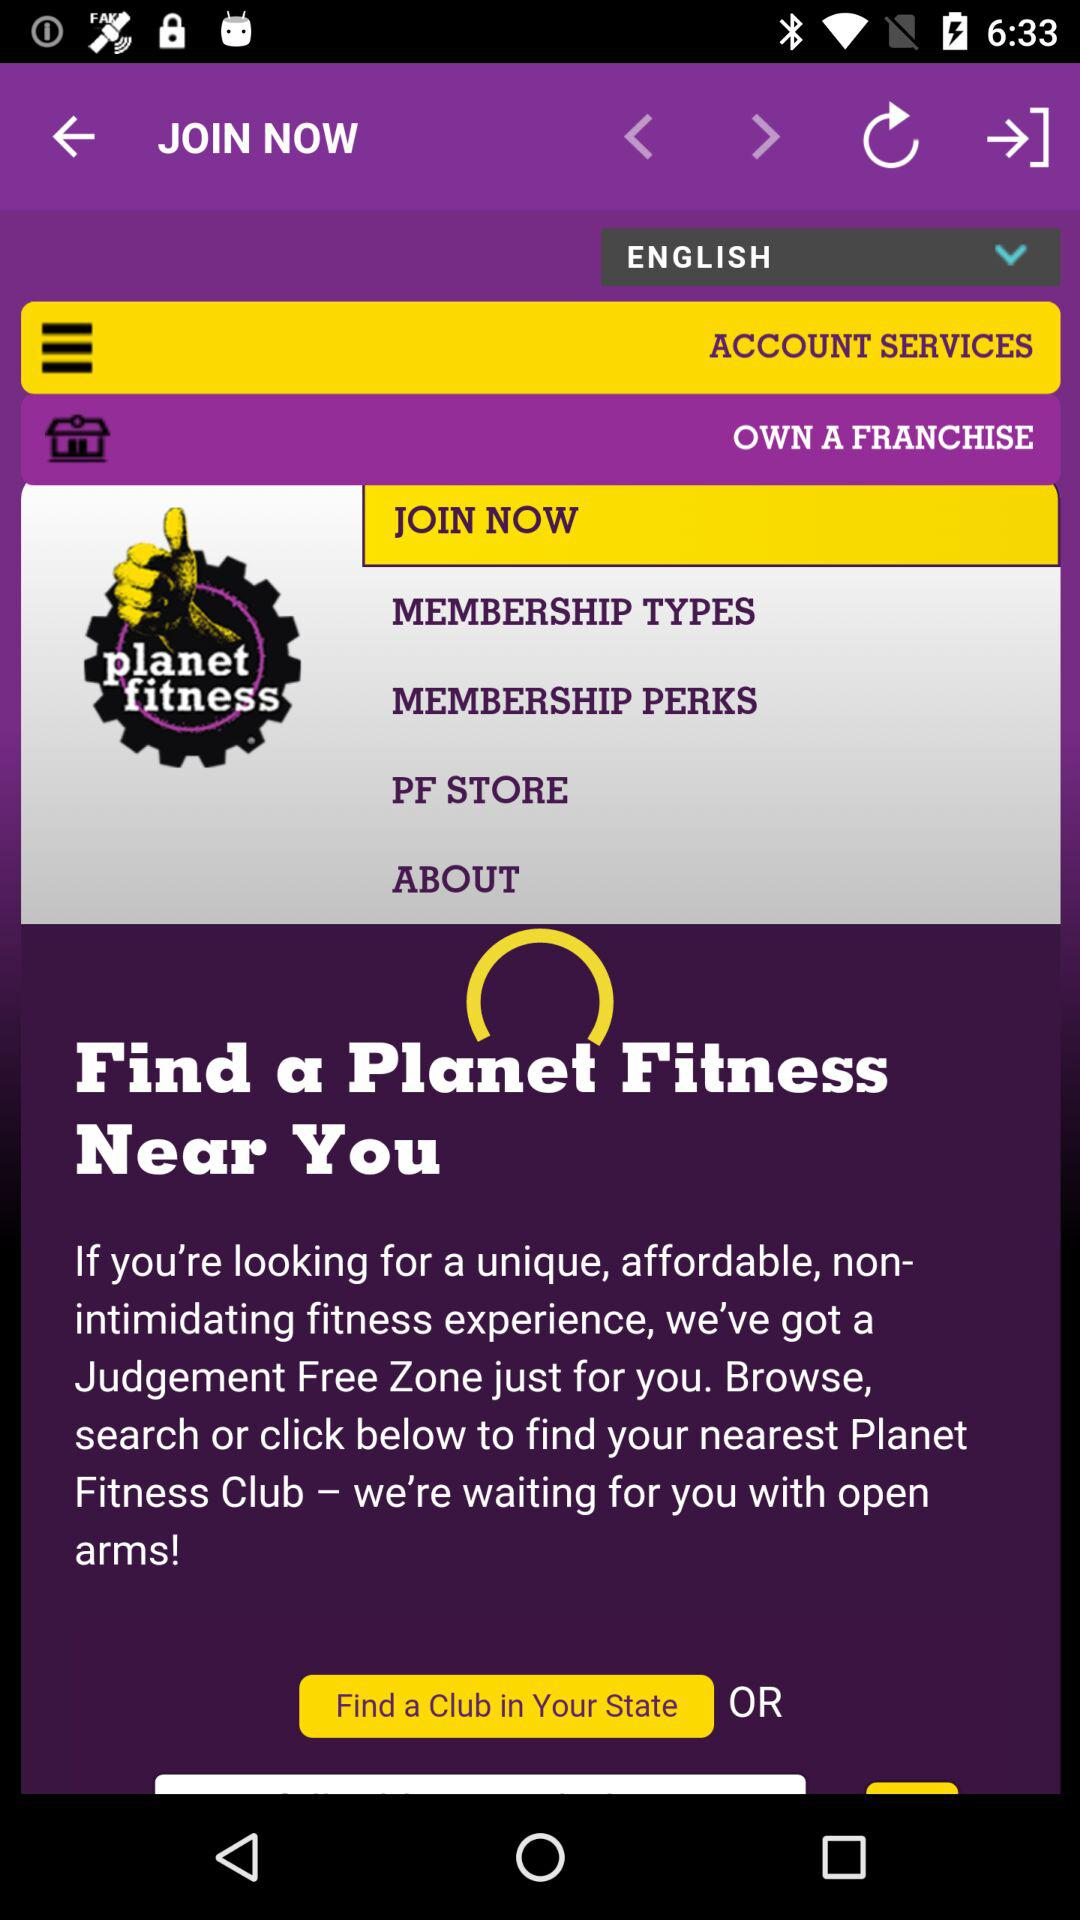Which language has been selected? The selected language is English. 